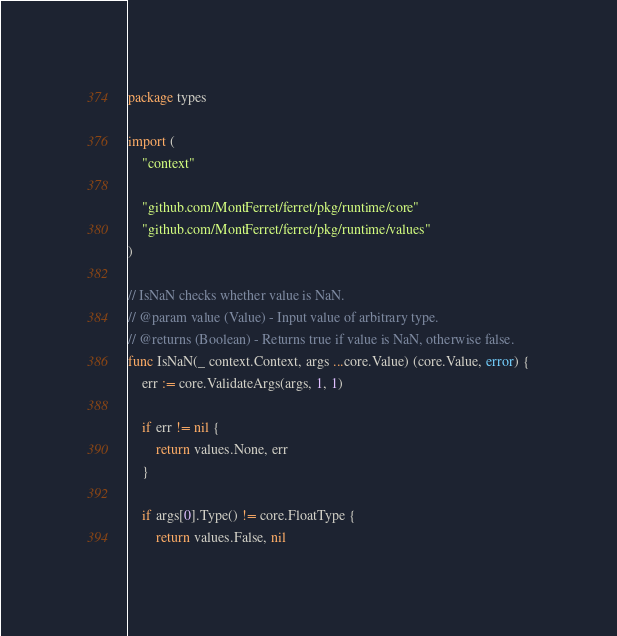<code> <loc_0><loc_0><loc_500><loc_500><_Go_>package types

import (
	"context"

	"github.com/MontFerret/ferret/pkg/runtime/core"
	"github.com/MontFerret/ferret/pkg/runtime/values"
)

// IsNaN checks whether value is NaN.
// @param value (Value) - Input value of arbitrary type.
// @returns (Boolean) - Returns true if value is NaN, otherwise false.
func IsNaN(_ context.Context, args ...core.Value) (core.Value, error) {
	err := core.ValidateArgs(args, 1, 1)

	if err != nil {
		return values.None, err
	}

	if args[0].Type() != core.FloatType {
		return values.False, nil</code> 